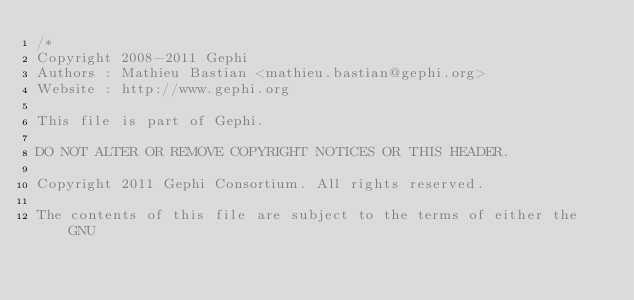<code> <loc_0><loc_0><loc_500><loc_500><_Java_>/*
Copyright 2008-2011 Gephi
Authors : Mathieu Bastian <mathieu.bastian@gephi.org>
Website : http://www.gephi.org

This file is part of Gephi.

DO NOT ALTER OR REMOVE COPYRIGHT NOTICES OR THIS HEADER.

Copyright 2011 Gephi Consortium. All rights reserved.

The contents of this file are subject to the terms of either the GNU</code> 